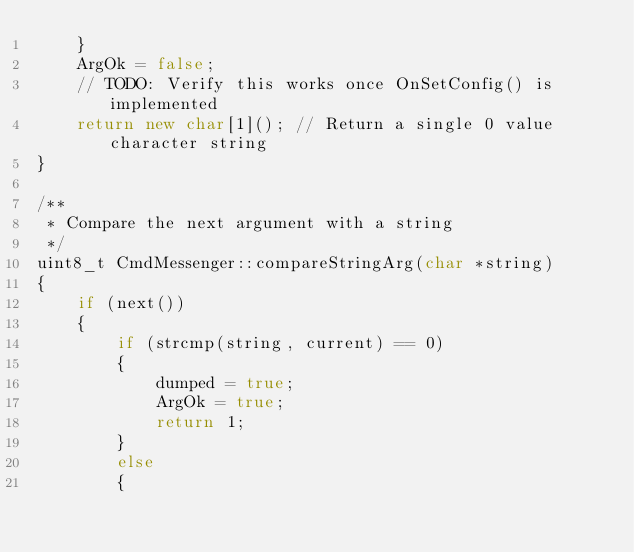Convert code to text. <code><loc_0><loc_0><loc_500><loc_500><_C++_>    }
    ArgOk = false;
    // TODO: Verify this works once OnSetConfig() is implemented
    return new char[1](); // Return a single 0 value character string
}

/**
 * Compare the next argument with a string
 */
uint8_t CmdMessenger::compareStringArg(char *string)
{
    if (next())
    {
        if (strcmp(string, current) == 0)
        {
            dumped = true;
            ArgOk = true;
            return 1;
        }
        else
        {</code> 